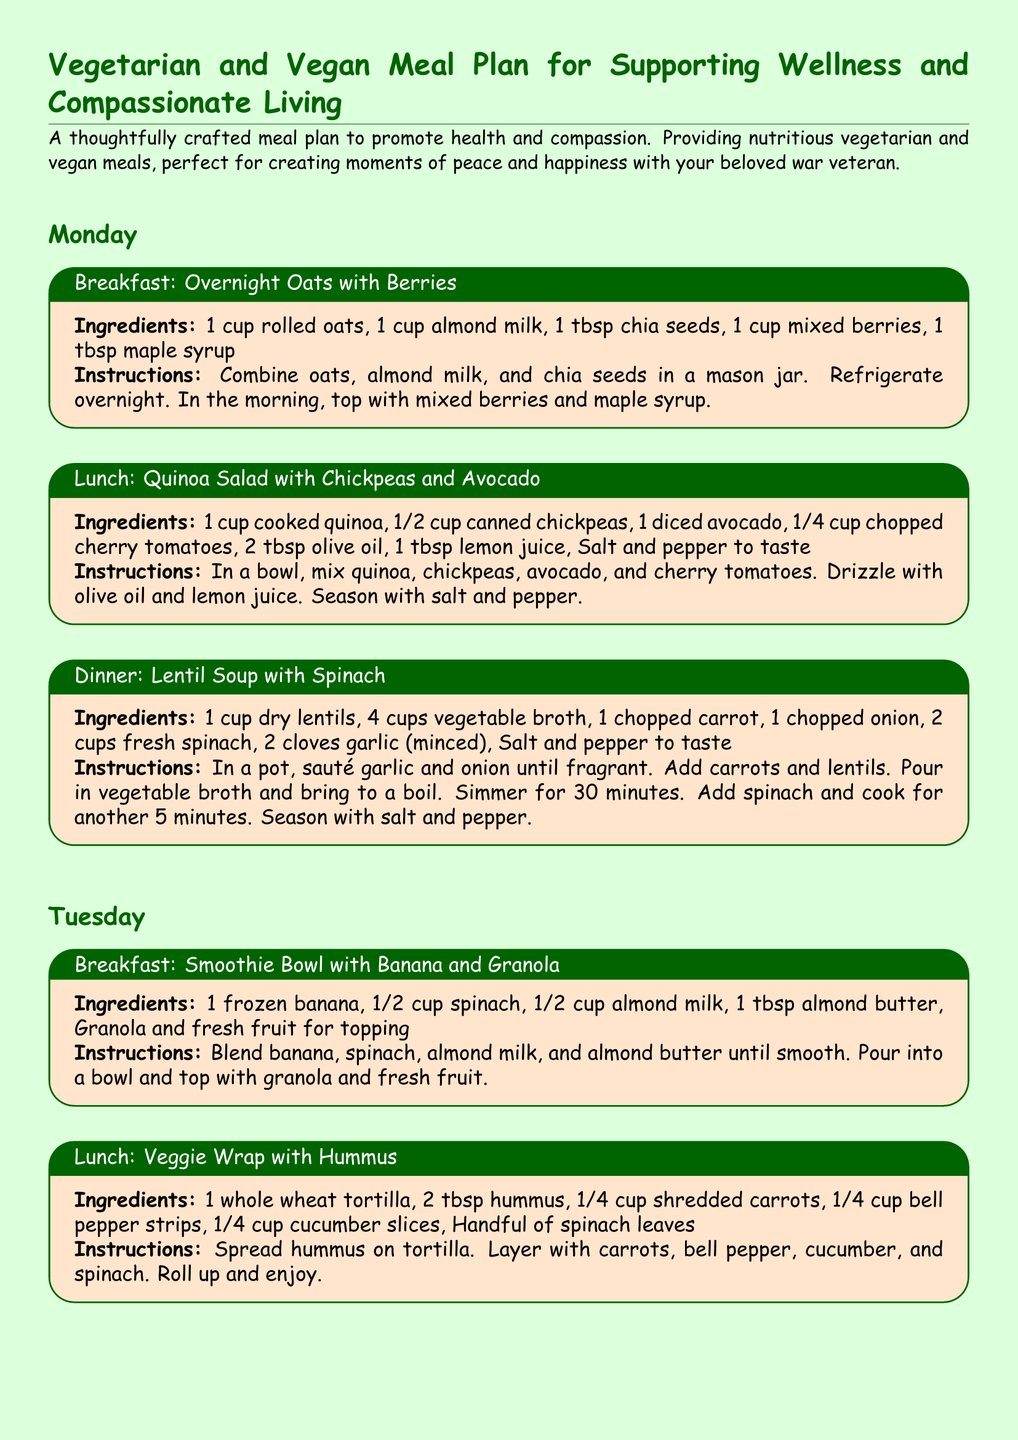What are the ingredients for the Overnight Oats? The ingredients listed for Overnight Oats include rolled oats, almond milk, chia seeds, mixed berries, and maple syrup.
Answer: 1 cup rolled oats, 1 cup almond milk, 1 tbsp chia seeds, 1 cup mixed berries, 1 tbsp maple syrup How many cups of vegetable broth are needed for the Lentil Soup? The recipe for Lentil Soup specifies the use of 4 cups of vegetable broth.
Answer: 4 cups What is served for lunch on Tuesday? The meal plan states that a Veggie Wrap with Hummus is served for lunch on Tuesday.
Answer: Veggie Wrap with Hummus What is the main source of protein in the Stir-Fried Tofu dish? Tofu is specified as the main source of protein in the Stir-Fried Tofu recipe.
Answer: Tofu How long should the lentils simmer in the soup? The instructions mention that the lentils should simmer for 30 minutes.
Answer: 30 minutes What type of tortilla is used in the Veggie Wrap? It states that a whole wheat tortilla is used in the Veggie Wrap.
Answer: Whole wheat tortilla What is the primary color theme of the meal plan document? The document has a light green color theme as seen in the background.
Answer: Light green Which breakfast option contains spinach? The Smoothie Bowl with Banana and Granola includes spinach in its ingredients.
Answer: Smoothie Bowl with Banana and Granola 